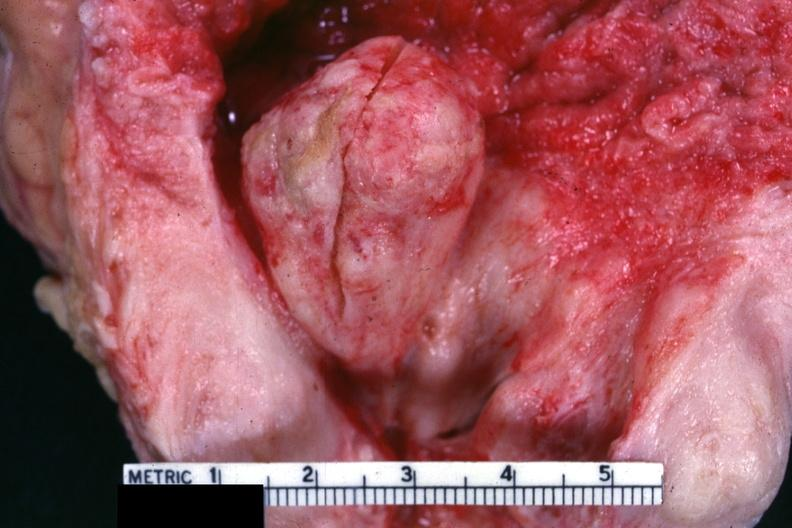s prostate present?
Answer the question using a single word or phrase. Yes 